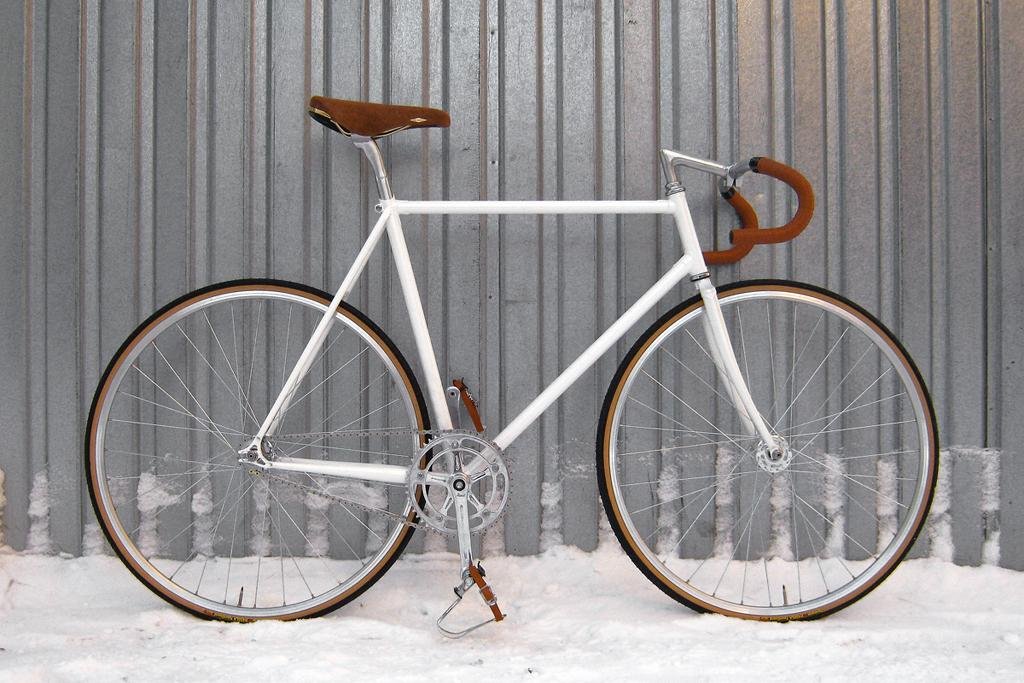What colors can be seen in the cycle in the image? The cycle has a white and brown color scheme in the image. Where is the cycle located in the image? The cycle is parked on the snow ground in the image. What can be seen in the background of the image? There is a silver roller shutter in the background of the image. What type of stove is being used to cook in the image? There is no stove or cooking activity present in the image. 